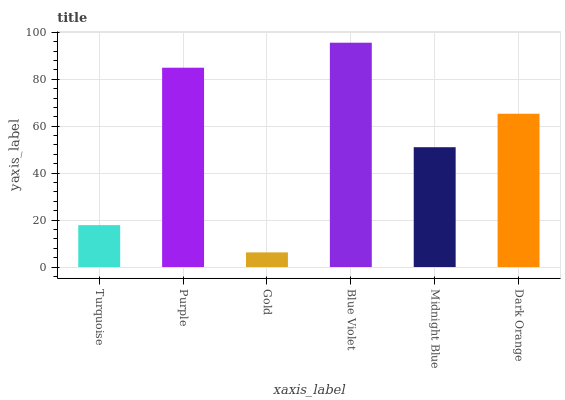Is Purple the minimum?
Answer yes or no. No. Is Purple the maximum?
Answer yes or no. No. Is Purple greater than Turquoise?
Answer yes or no. Yes. Is Turquoise less than Purple?
Answer yes or no. Yes. Is Turquoise greater than Purple?
Answer yes or no. No. Is Purple less than Turquoise?
Answer yes or no. No. Is Dark Orange the high median?
Answer yes or no. Yes. Is Midnight Blue the low median?
Answer yes or no. Yes. Is Midnight Blue the high median?
Answer yes or no. No. Is Gold the low median?
Answer yes or no. No. 